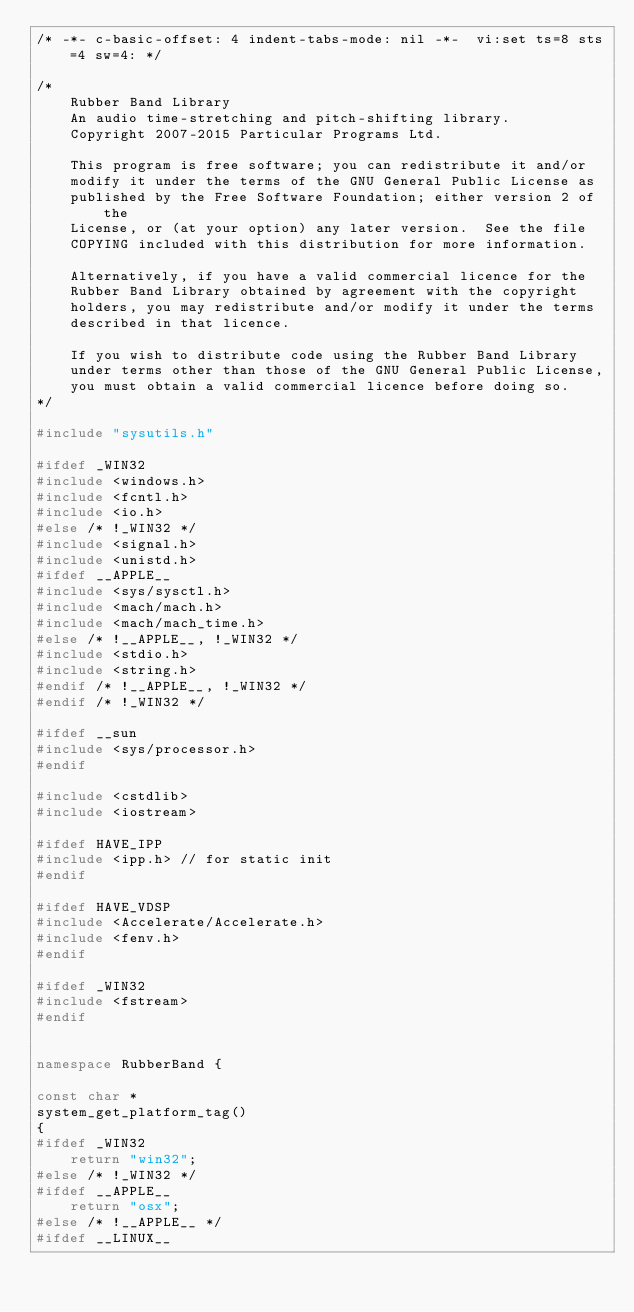Convert code to text. <code><loc_0><loc_0><loc_500><loc_500><_C++_>/* -*- c-basic-offset: 4 indent-tabs-mode: nil -*-  vi:set ts=8 sts=4 sw=4: */

/*
    Rubber Band Library
    An audio time-stretching and pitch-shifting library.
    Copyright 2007-2015 Particular Programs Ltd.

    This program is free software; you can redistribute it and/or
    modify it under the terms of the GNU General Public License as
    published by the Free Software Foundation; either version 2 of the
    License, or (at your option) any later version.  See the file
    COPYING included with this distribution for more information.

    Alternatively, if you have a valid commercial licence for the
    Rubber Band Library obtained by agreement with the copyright
    holders, you may redistribute and/or modify it under the terms
    described in that licence.

    If you wish to distribute code using the Rubber Band Library
    under terms other than those of the GNU General Public License,
    you must obtain a valid commercial licence before doing so.
*/

#include "sysutils.h"

#ifdef _WIN32
#include <windows.h>
#include <fcntl.h>
#include <io.h>
#else /* !_WIN32 */
#include <signal.h>
#include <unistd.h>
#ifdef __APPLE__
#include <sys/sysctl.h>
#include <mach/mach.h>
#include <mach/mach_time.h>
#else /* !__APPLE__, !_WIN32 */
#include <stdio.h>
#include <string.h>
#endif /* !__APPLE__, !_WIN32 */
#endif /* !_WIN32 */

#ifdef __sun
#include <sys/processor.h>
#endif

#include <cstdlib>
#include <iostream>

#ifdef HAVE_IPP
#include <ipp.h> // for static init
#endif

#ifdef HAVE_VDSP
#include <Accelerate/Accelerate.h>
#include <fenv.h>
#endif

#ifdef _WIN32
#include <fstream>
#endif


namespace RubberBand {

const char *
system_get_platform_tag()
{
#ifdef _WIN32
    return "win32";
#else /* !_WIN32 */
#ifdef __APPLE__
    return "osx";
#else /* !__APPLE__ */
#ifdef __LINUX__</code> 